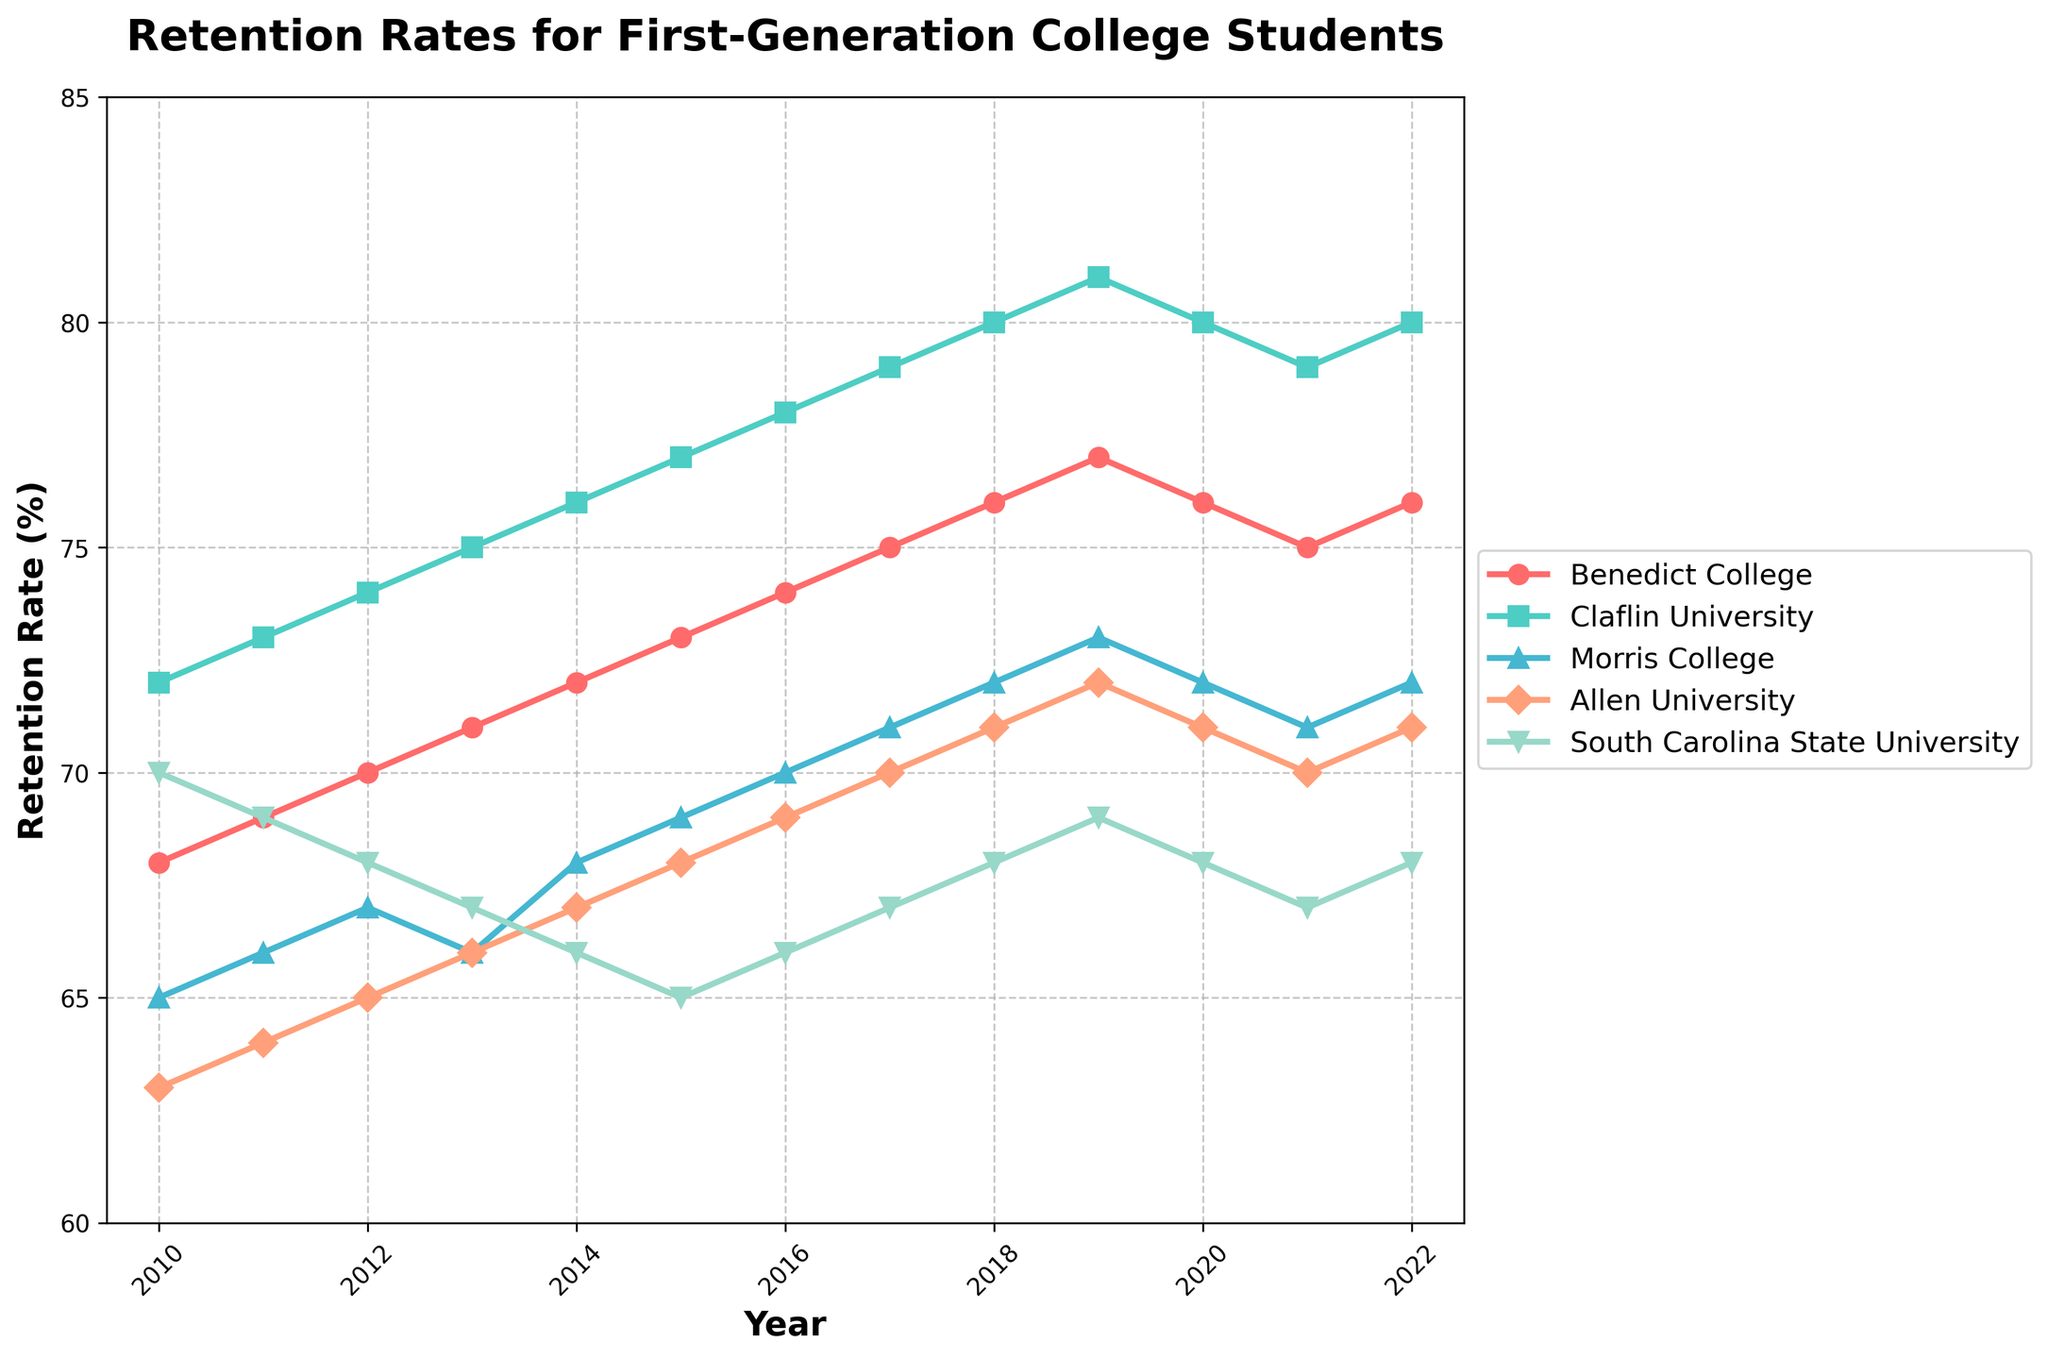What is the trend of retention rates at Benedict College from 2010 to 2022? To determine the trend, observe the line chart corresponding to Benedict College. Starting in 2010, the retention rate steadily increased from 68% to 77% in 2019, then slightly decreased in 2020 and 2021 before rising again in 2022.
Answer: Steady increase with a slight decline in 2020 and 2021 Which institution had the highest retention rate in 2022? Look at the lines on the chart and identify the endpoint values for each institution in 2022. Claflin University has the highest retention rate at the end.
Answer: Claflin University What was the difference in retention rates between Benedict College and Allen University in 2015? Check the retention rates for Benedict College and Allen University in 2015 from the line chart. The rates were 73% and 68%, respectively. The difference is 73% - 68%.
Answer: 5% Which year saw the biggest increase in retention rate for Benedict College? Analyze the retention rate line for Benedict College and compare the year-over-year changes. The biggest increase occurred from 2010 to 2011, when the rate went up by 1%.
Answer: 2013 to 2014 How did the retention rate for South Carolina State University change from 2017 to 2022? Track the retention rate line for South Carolina State University from 2017 to 2022. The rate increased slightly from 67% in 2017 to 69% in 2019, then decreased back to 67% by 2022.
Answer: Increased then decreased What is the average retention rate for Morris College over the entire period? Add all retention rates for Morris College from 2010 to 2022 and divide by the number of years (13). The sum is 936%, so the average is 936/13.
Answer: 72% How do the retention rates of Benedict College and Claflin University compare in the year 2018? Compare the two lines in 2018. Benedict College had a retention rate of 76%, whereas Claflin University had 80%.
Answer: Claflin University is higher What is the median retention rate for Allen University from 2010 to 2022? Arrange retention rates of Allen University (63, 64, 65, 66, 67, 68, 69, 70, 71, 72, 71, 71, 71), which has 13 values. The median is the middle value, which is 69%.
Answer: 69% Which institution showed the most consistent (least variable) retention rates over the years? Examine the lines for each institution. Allen University shows the least variation, with its retention rates ranging from 63% to 72%.
Answer: Allen University 